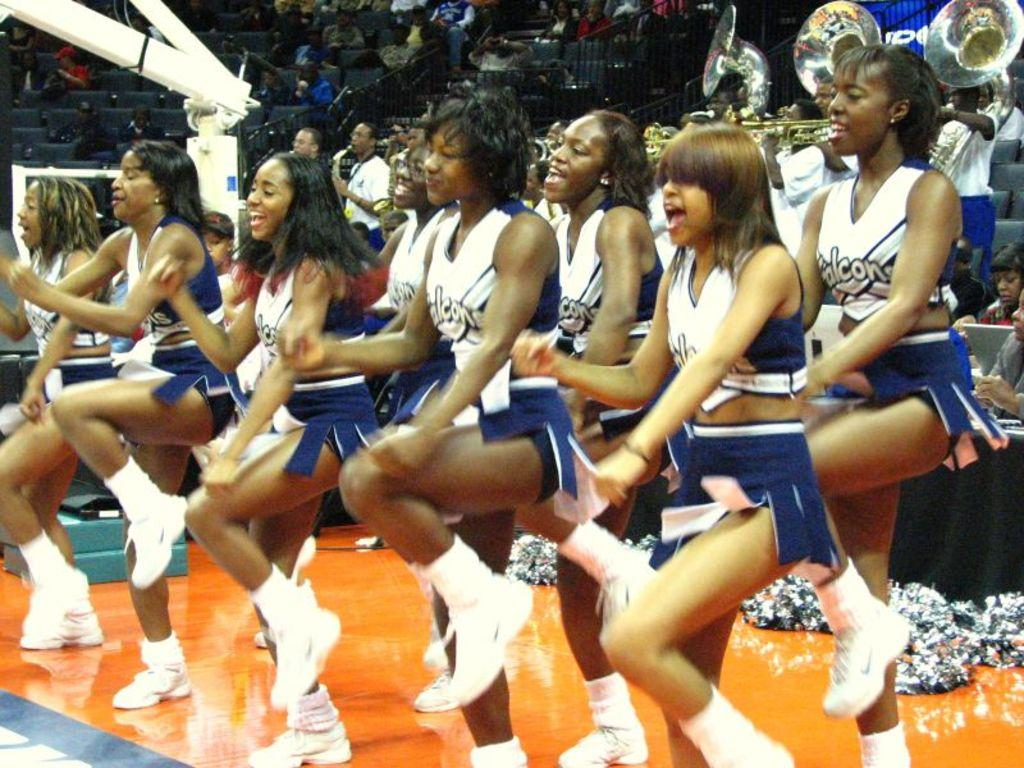<image>
Describe the image concisely. The girls in the picture are cheering for the Falcons. 